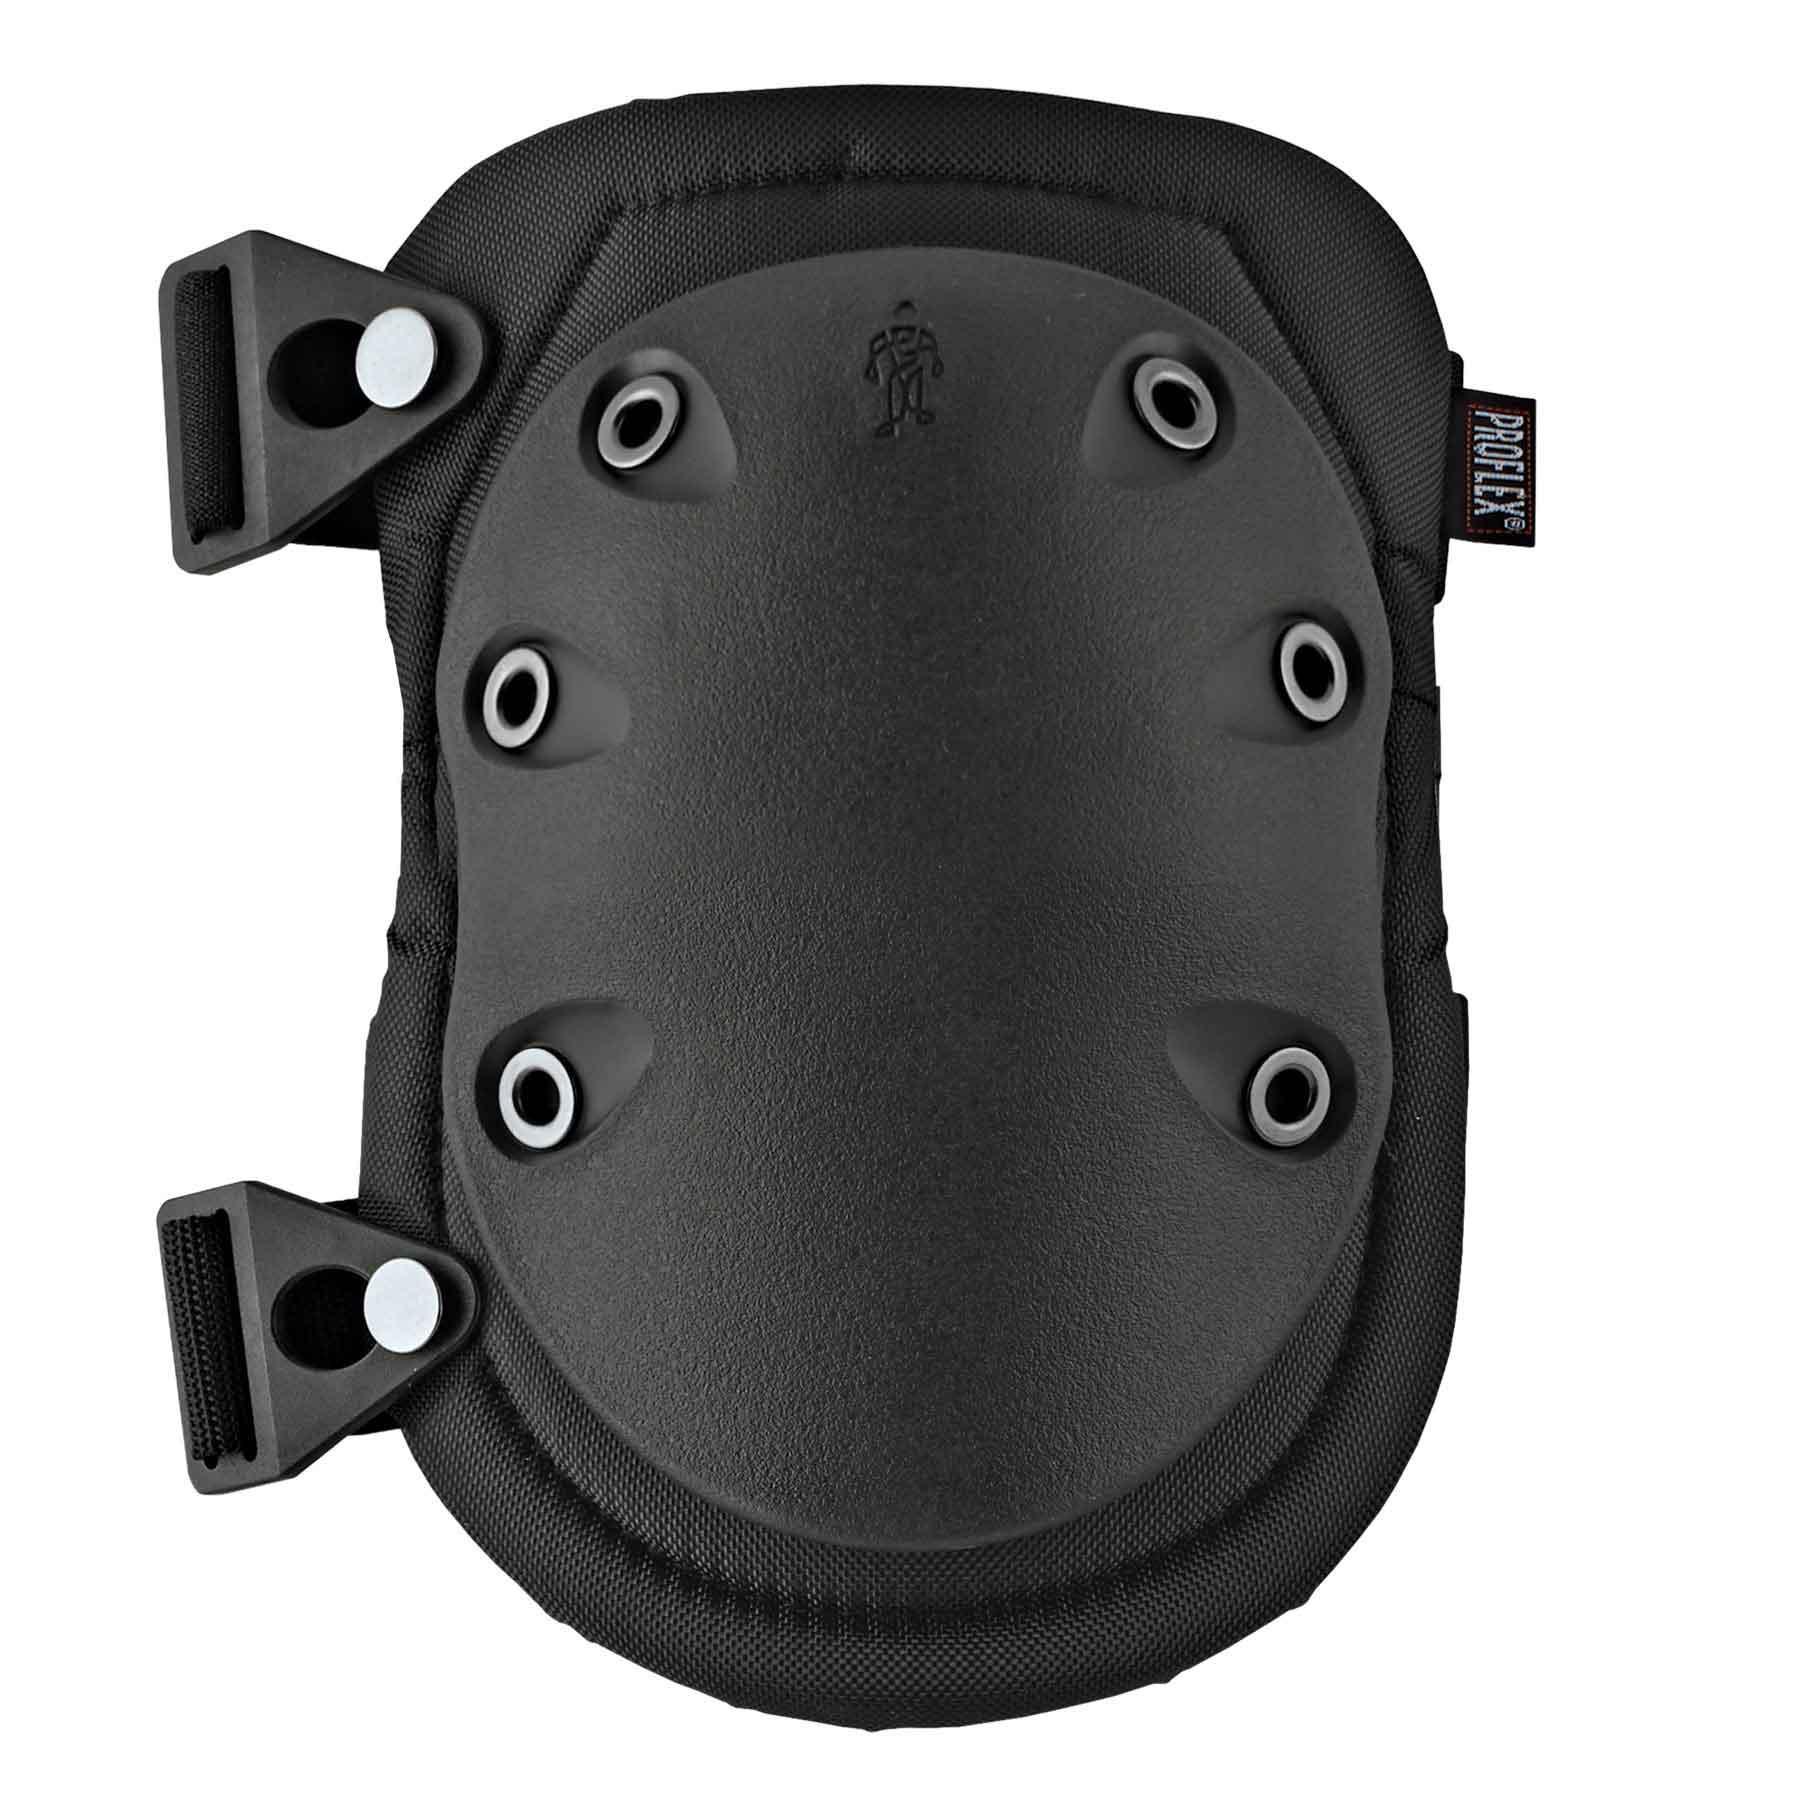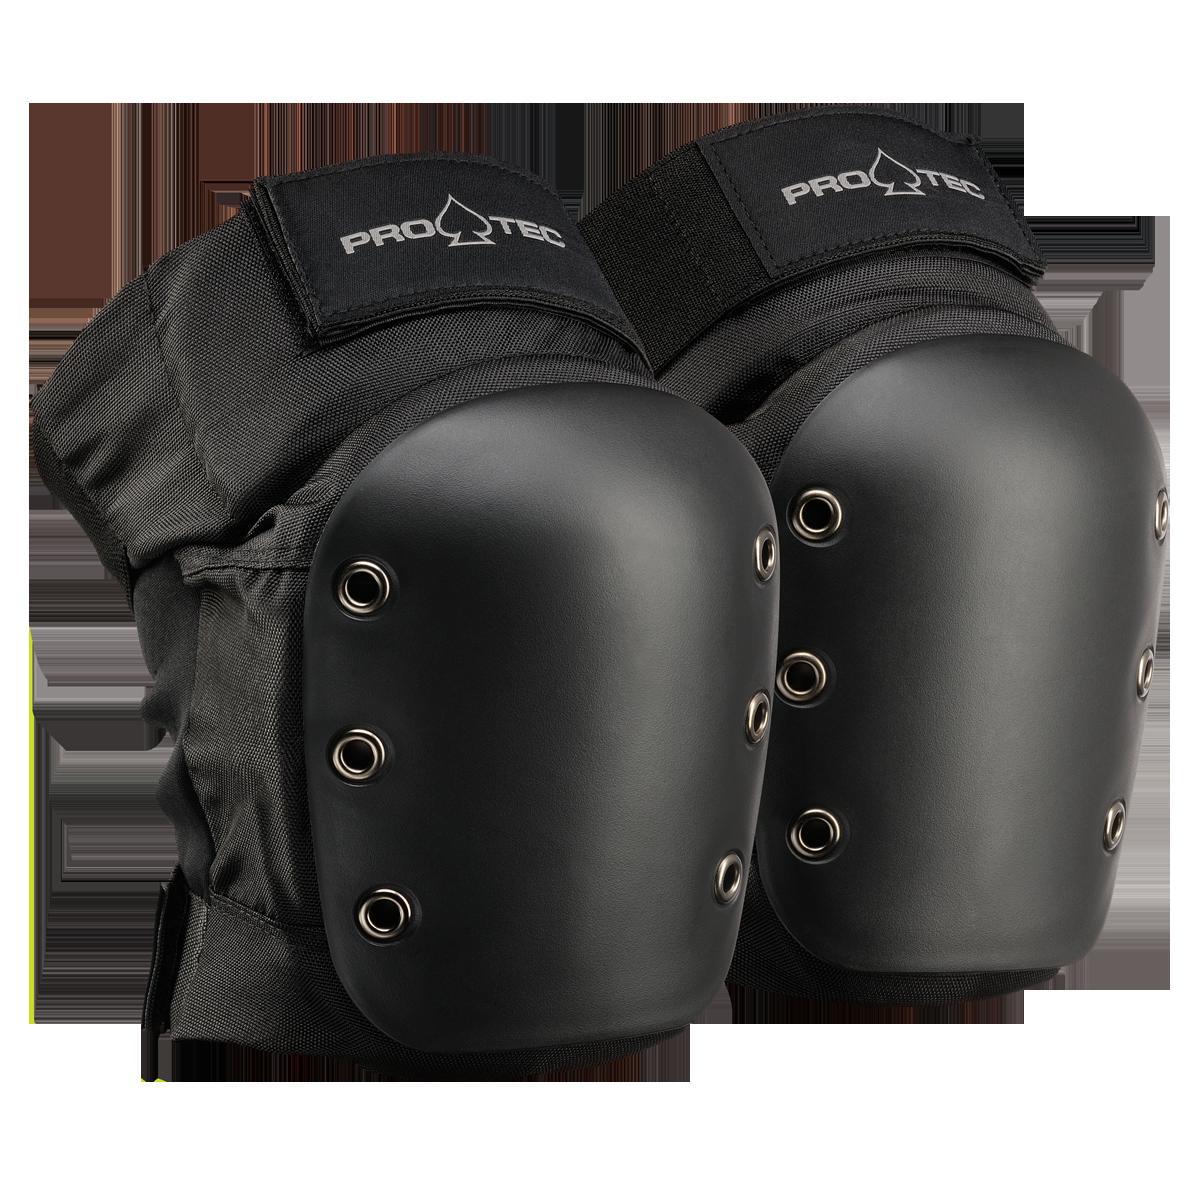The first image is the image on the left, the second image is the image on the right. Examine the images to the left and right. Is the description "An image shows a pair of unworn, smooth black kneepads with no texture turned rightward." accurate? Answer yes or no. Yes. The first image is the image on the left, the second image is the image on the right. Evaluate the accuracy of this statement regarding the images: "Right image shows a pair of black kneepads turned rightward.". Is it true? Answer yes or no. Yes. 